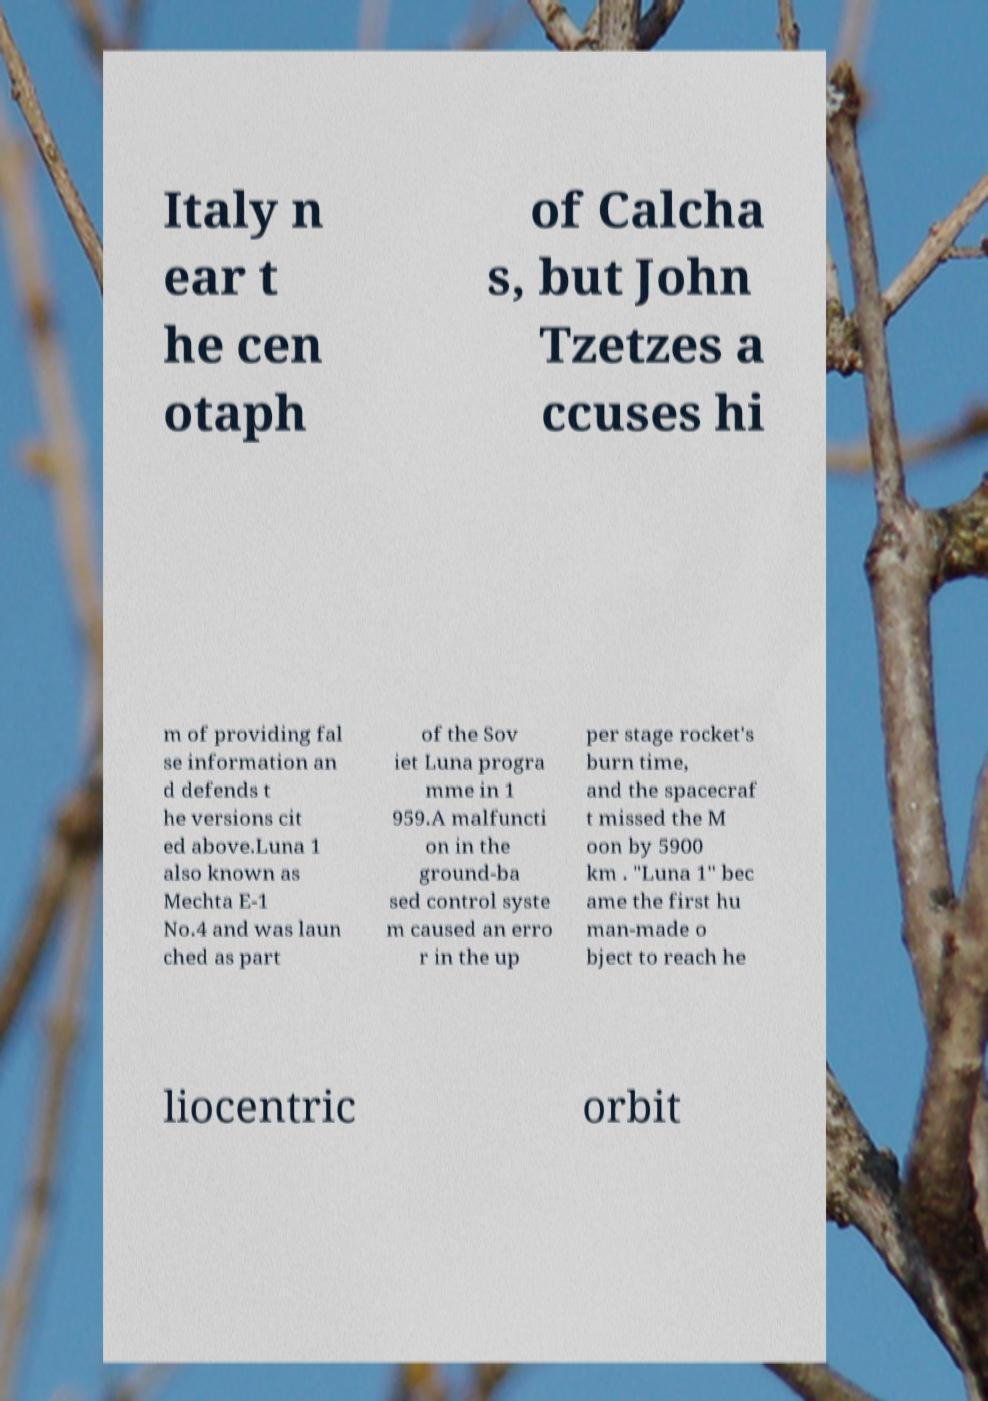Could you extract and type out the text from this image? Italy n ear t he cen otaph of Calcha s, but John Tzetzes a ccuses hi m of providing fal se information an d defends t he versions cit ed above.Luna 1 also known as Mechta E-1 No.4 and was laun ched as part of the Sov iet Luna progra mme in 1 959.A malfuncti on in the ground-ba sed control syste m caused an erro r in the up per stage rocket's burn time, and the spacecraf t missed the M oon by 5900 km . "Luna 1" bec ame the first hu man-made o bject to reach he liocentric orbit 